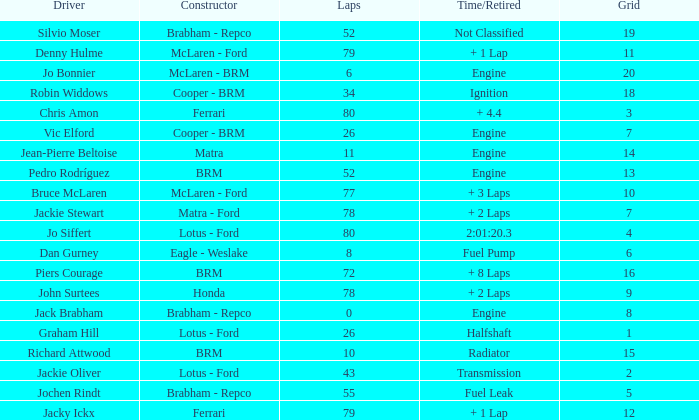What driver has a grid greater than 19? Jo Bonnier. 